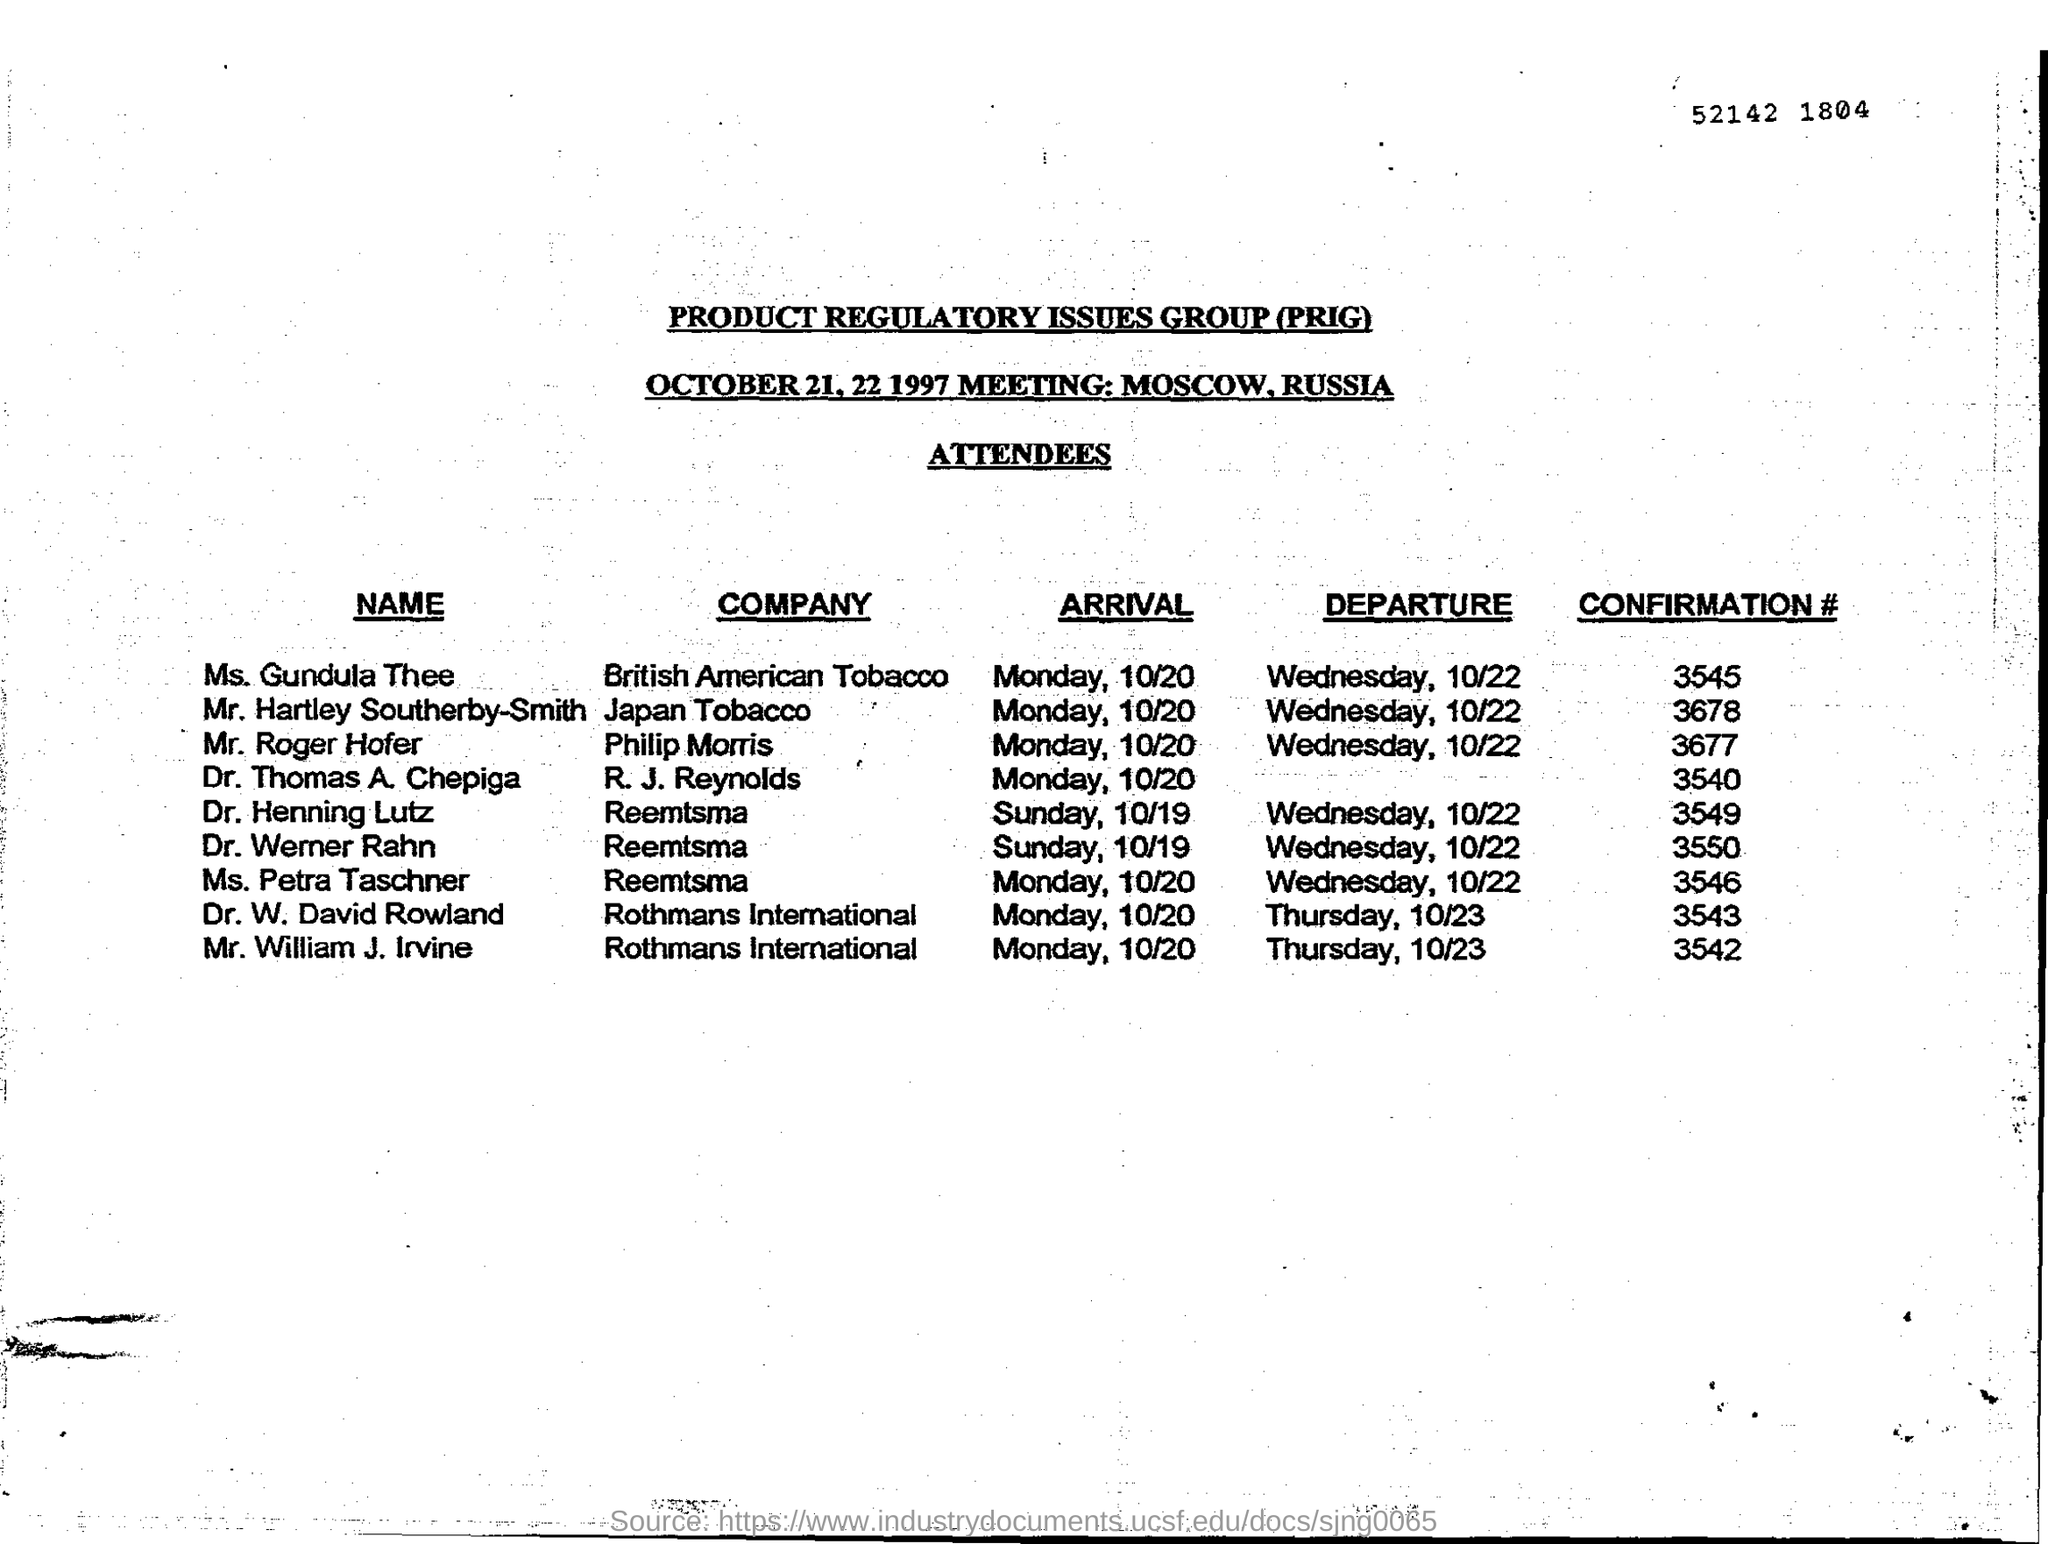Point out several critical features in this image. The meeting is conducted in Moscow. Rothmans International's attendees will depart on Thursday. Product Regulatory Issues Group" is an acronym that stands for "PRIG". Hartley Southerby-Smith works for Japan Tobacco. The confirmation number of Dr. Werner Rahn is 3550. 